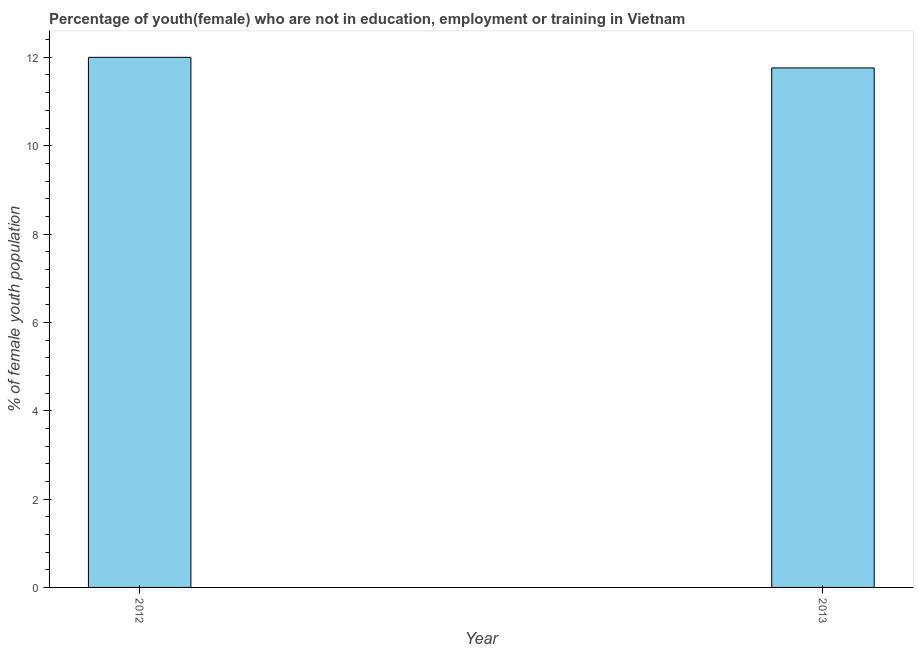What is the title of the graph?
Your answer should be compact. Percentage of youth(female) who are not in education, employment or training in Vietnam. What is the label or title of the X-axis?
Your answer should be compact. Year. What is the label or title of the Y-axis?
Provide a short and direct response. % of female youth population. What is the unemployed female youth population in 2013?
Make the answer very short. 11.76. Across all years, what is the minimum unemployed female youth population?
Your answer should be compact. 11.76. What is the sum of the unemployed female youth population?
Ensure brevity in your answer.  23.76. What is the difference between the unemployed female youth population in 2012 and 2013?
Keep it short and to the point. 0.24. What is the average unemployed female youth population per year?
Ensure brevity in your answer.  11.88. What is the median unemployed female youth population?
Your answer should be compact. 11.88. In how many years, is the unemployed female youth population greater than 1.2 %?
Keep it short and to the point. 2. What is the ratio of the unemployed female youth population in 2012 to that in 2013?
Your answer should be very brief. 1.02. Is the unemployed female youth population in 2012 less than that in 2013?
Your response must be concise. No. In how many years, is the unemployed female youth population greater than the average unemployed female youth population taken over all years?
Your response must be concise. 1. How many bars are there?
Your response must be concise. 2. How many years are there in the graph?
Offer a very short reply. 2. What is the difference between two consecutive major ticks on the Y-axis?
Give a very brief answer. 2. What is the % of female youth population of 2013?
Your answer should be very brief. 11.76. What is the difference between the % of female youth population in 2012 and 2013?
Provide a short and direct response. 0.24. 